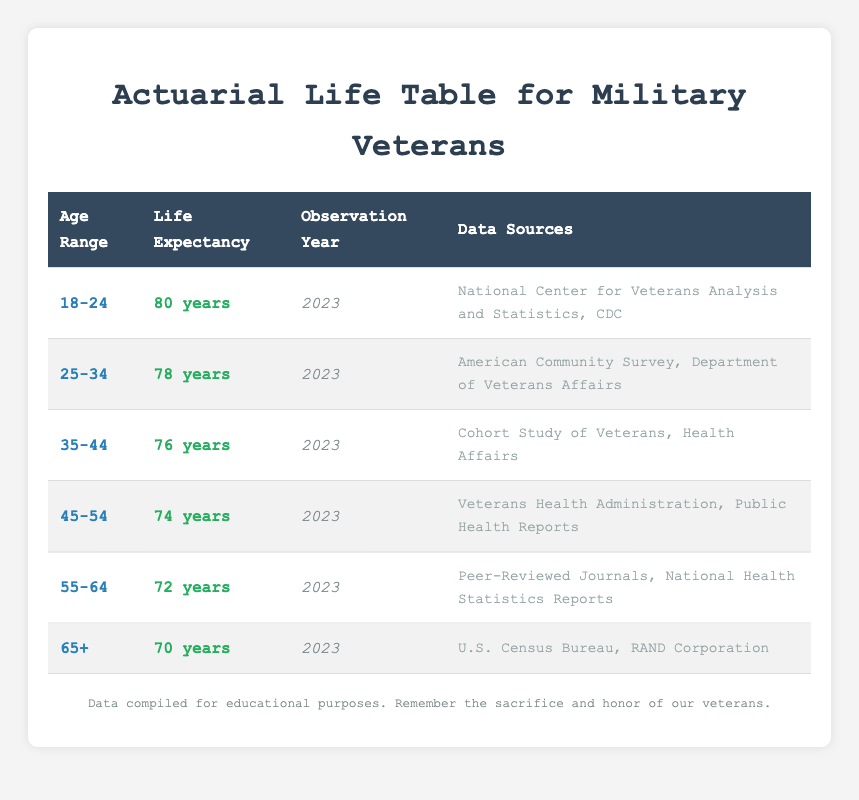What is the life expectancy of veterans in the 45-54 age range? The table specifies the life expectancy for veterans in the 45-54 age range as 74 years.
Answer: 74 years How many years of life expectancy do veterans aged 55-64 have compared to those aged 25-34? Veterans aged 55-64 have a life expectancy of 72 years, while those aged 25-34 have a life expectancy of 78 years. The difference is 78 - 72 = 6 years.
Answer: 6 years Is the life expectancy of veterans in the 35-44 age group lower than that of those in the 65+ age group? The life expectancy for veterans aged 35-44 is 76 years, and for those aged 65+, it is 70 years. Since 76 is greater than 70, the statement is true.
Answer: Yes What is the average life expectancy of veterans across all age groups listed in the table? The life expectancies for all age groups are: 80, 78, 76, 74, 72, and 70. Adding these gives a total of 450 years. We have 6 age groups, so the average is 450 / 6 = 75 years.
Answer: 75 years Which age group has the highest life expectancy among veterans? The table shows that the age group 18-24 has the highest life expectancy at 80 years, as no other age group exceeds this value.
Answer: 18-24 age group How many sources were used to compile the data for the veterans aged 55-64? The table lists two data sources for the 55-64 age group: Peer-Reviewed Journals and National Health Statistics Reports. Therefore, the total is 2 sources.
Answer: 2 sources Is it true that the life expectancy of veterans decreases with increasing age? The life expectancy values for each age group show a descending trend: 80, 78, 76, 74, 72, and 70. This confirms that higher age is associated with lower life expectancy.
Answer: Yes Which age group has a life expectancy that is exactly 6 years less than the life expectancy of veterans aged 25-34? Veterans in the 35-44 age group have a life expectancy of 76 years, which is indeed 6 years less than the 78 years of those aged 25-34 (78 - 76 = 2 years).
Answer: 35-44 age group 